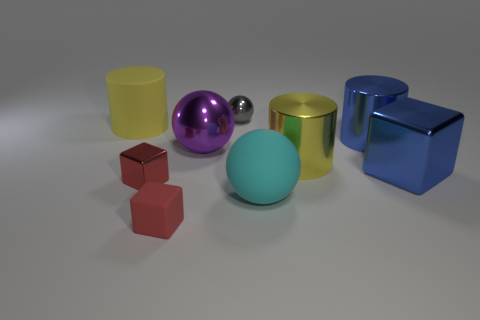Are there an equal number of cylinders right of the big cyan thing and small red metallic cylinders? No, there are not an equal number of cylinders. To the right of the big cyan sphere, there are two cylinders – one yellow and one gold. Whereas, there is only one small red metallic cube visible in the image. 